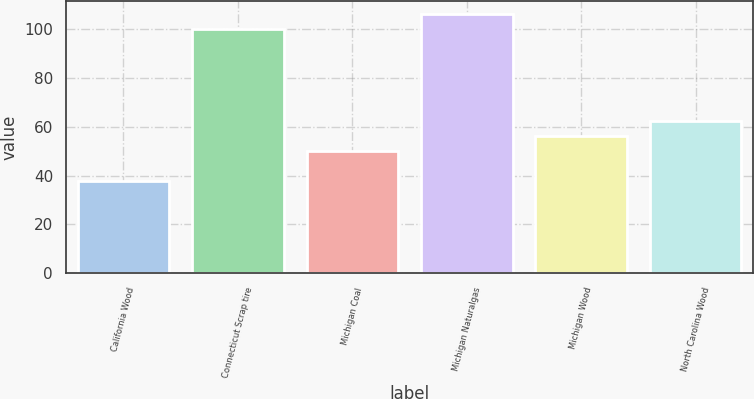Convert chart to OTSL. <chart><loc_0><loc_0><loc_500><loc_500><bar_chart><fcel>California Wood<fcel>Connecticut Scrap tire<fcel>Michigan Coal<fcel>Michigan Naturalgas<fcel>Michigan Wood<fcel>North Carolina Wood<nl><fcel>37.8<fcel>100<fcel>50<fcel>106.22<fcel>56.22<fcel>62.44<nl></chart> 